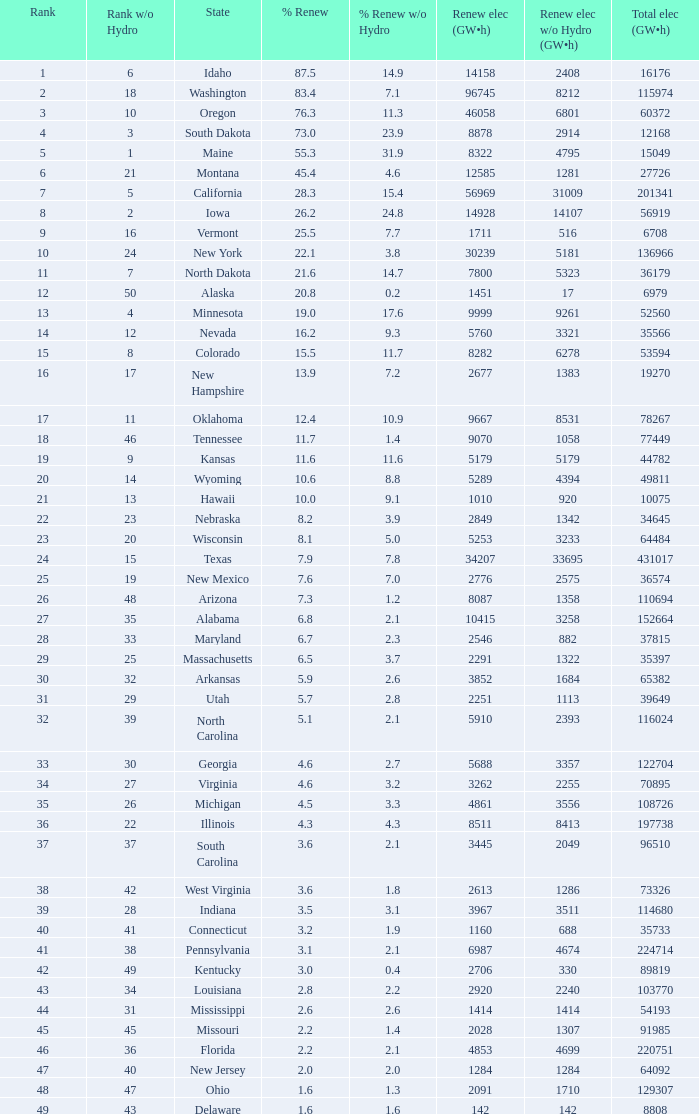Which state has 5179 (gw×h) of green energy not considering hydrogen power? Kansas. 